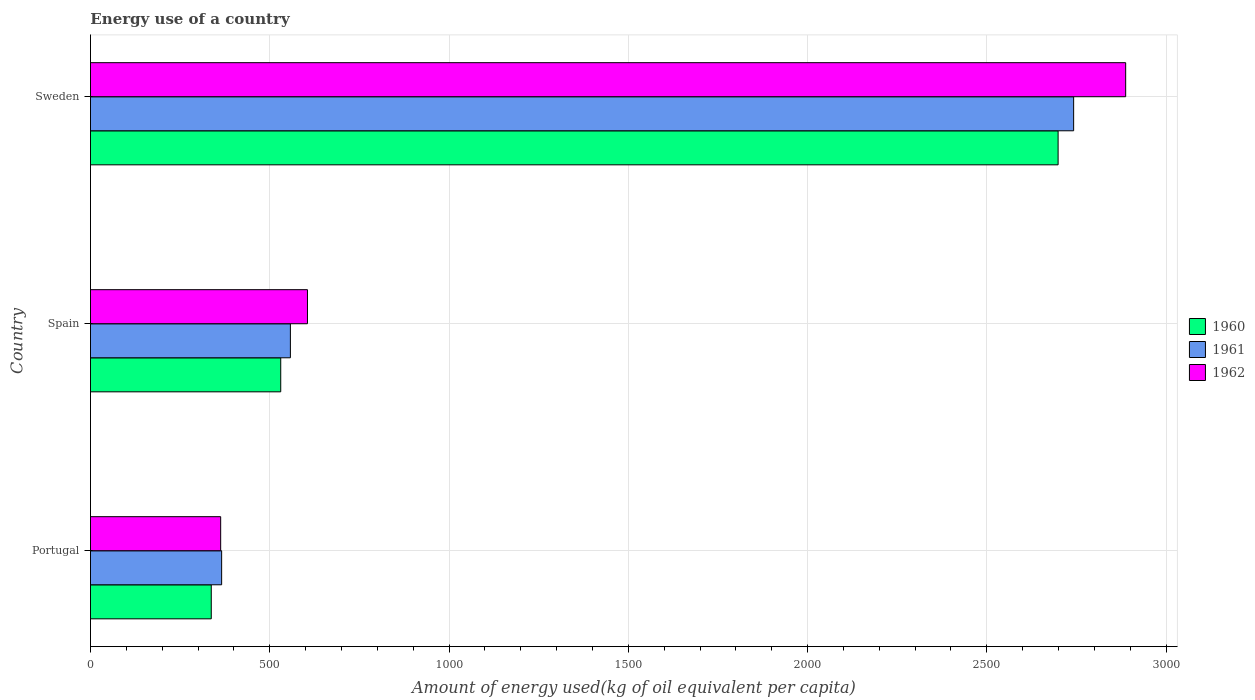How many groups of bars are there?
Make the answer very short. 3. What is the amount of energy used in in 1960 in Spain?
Make the answer very short. 530.66. Across all countries, what is the maximum amount of energy used in in 1962?
Your response must be concise. 2887.24. Across all countries, what is the minimum amount of energy used in in 1960?
Ensure brevity in your answer.  336.91. In which country was the amount of energy used in in 1961 maximum?
Your response must be concise. Sweden. What is the total amount of energy used in in 1960 in the graph?
Your response must be concise. 3566.37. What is the difference between the amount of energy used in in 1962 in Portugal and that in Sweden?
Your answer should be compact. -2524.07. What is the difference between the amount of energy used in in 1962 in Spain and the amount of energy used in in 1961 in Portugal?
Your answer should be compact. 239.38. What is the average amount of energy used in in 1961 per country?
Make the answer very short. 1221.85. What is the difference between the amount of energy used in in 1960 and amount of energy used in in 1962 in Sweden?
Keep it short and to the point. -188.44. What is the ratio of the amount of energy used in in 1961 in Spain to that in Sweden?
Your answer should be compact. 0.2. What is the difference between the highest and the second highest amount of energy used in in 1960?
Offer a very short reply. 2168.13. What is the difference between the highest and the lowest amount of energy used in in 1961?
Your response must be concise. 2376.28. What does the 2nd bar from the bottom in Sweden represents?
Offer a terse response. 1961. How many bars are there?
Your response must be concise. 9. Are all the bars in the graph horizontal?
Give a very brief answer. Yes. What is the difference between two consecutive major ticks on the X-axis?
Your answer should be compact. 500. Are the values on the major ticks of X-axis written in scientific E-notation?
Your answer should be very brief. No. Does the graph contain any zero values?
Provide a short and direct response. No. How are the legend labels stacked?
Your answer should be compact. Vertical. What is the title of the graph?
Keep it short and to the point. Energy use of a country. What is the label or title of the X-axis?
Ensure brevity in your answer.  Amount of energy used(kg of oil equivalent per capita). What is the label or title of the Y-axis?
Give a very brief answer. Country. What is the Amount of energy used(kg of oil equivalent per capita) in 1960 in Portugal?
Your answer should be very brief. 336.91. What is the Amount of energy used(kg of oil equivalent per capita) of 1961 in Portugal?
Provide a succinct answer. 365.84. What is the Amount of energy used(kg of oil equivalent per capita) of 1962 in Portugal?
Make the answer very short. 363.16. What is the Amount of energy used(kg of oil equivalent per capita) of 1960 in Spain?
Provide a succinct answer. 530.66. What is the Amount of energy used(kg of oil equivalent per capita) in 1961 in Spain?
Keep it short and to the point. 557.6. What is the Amount of energy used(kg of oil equivalent per capita) of 1962 in Spain?
Provide a short and direct response. 605.22. What is the Amount of energy used(kg of oil equivalent per capita) of 1960 in Sweden?
Provide a succinct answer. 2698.79. What is the Amount of energy used(kg of oil equivalent per capita) of 1961 in Sweden?
Your response must be concise. 2742.12. What is the Amount of energy used(kg of oil equivalent per capita) of 1962 in Sweden?
Provide a succinct answer. 2887.24. Across all countries, what is the maximum Amount of energy used(kg of oil equivalent per capita) of 1960?
Ensure brevity in your answer.  2698.79. Across all countries, what is the maximum Amount of energy used(kg of oil equivalent per capita) of 1961?
Offer a very short reply. 2742.12. Across all countries, what is the maximum Amount of energy used(kg of oil equivalent per capita) of 1962?
Offer a very short reply. 2887.24. Across all countries, what is the minimum Amount of energy used(kg of oil equivalent per capita) of 1960?
Your answer should be compact. 336.91. Across all countries, what is the minimum Amount of energy used(kg of oil equivalent per capita) of 1961?
Provide a succinct answer. 365.84. Across all countries, what is the minimum Amount of energy used(kg of oil equivalent per capita) of 1962?
Offer a very short reply. 363.16. What is the total Amount of energy used(kg of oil equivalent per capita) of 1960 in the graph?
Provide a short and direct response. 3566.37. What is the total Amount of energy used(kg of oil equivalent per capita) of 1961 in the graph?
Provide a succinct answer. 3665.56. What is the total Amount of energy used(kg of oil equivalent per capita) in 1962 in the graph?
Offer a terse response. 3855.62. What is the difference between the Amount of energy used(kg of oil equivalent per capita) of 1960 in Portugal and that in Spain?
Your answer should be very brief. -193.75. What is the difference between the Amount of energy used(kg of oil equivalent per capita) in 1961 in Portugal and that in Spain?
Your answer should be compact. -191.76. What is the difference between the Amount of energy used(kg of oil equivalent per capita) in 1962 in Portugal and that in Spain?
Give a very brief answer. -242.06. What is the difference between the Amount of energy used(kg of oil equivalent per capita) in 1960 in Portugal and that in Sweden?
Keep it short and to the point. -2361.88. What is the difference between the Amount of energy used(kg of oil equivalent per capita) of 1961 in Portugal and that in Sweden?
Provide a succinct answer. -2376.28. What is the difference between the Amount of energy used(kg of oil equivalent per capita) of 1962 in Portugal and that in Sweden?
Ensure brevity in your answer.  -2524.07. What is the difference between the Amount of energy used(kg of oil equivalent per capita) of 1960 in Spain and that in Sweden?
Make the answer very short. -2168.13. What is the difference between the Amount of energy used(kg of oil equivalent per capita) of 1961 in Spain and that in Sweden?
Give a very brief answer. -2184.52. What is the difference between the Amount of energy used(kg of oil equivalent per capita) of 1962 in Spain and that in Sweden?
Your response must be concise. -2282.01. What is the difference between the Amount of energy used(kg of oil equivalent per capita) in 1960 in Portugal and the Amount of energy used(kg of oil equivalent per capita) in 1961 in Spain?
Make the answer very short. -220.69. What is the difference between the Amount of energy used(kg of oil equivalent per capita) of 1960 in Portugal and the Amount of energy used(kg of oil equivalent per capita) of 1962 in Spain?
Offer a very short reply. -268.31. What is the difference between the Amount of energy used(kg of oil equivalent per capita) in 1961 in Portugal and the Amount of energy used(kg of oil equivalent per capita) in 1962 in Spain?
Your answer should be compact. -239.38. What is the difference between the Amount of energy used(kg of oil equivalent per capita) of 1960 in Portugal and the Amount of energy used(kg of oil equivalent per capita) of 1961 in Sweden?
Ensure brevity in your answer.  -2405.21. What is the difference between the Amount of energy used(kg of oil equivalent per capita) of 1960 in Portugal and the Amount of energy used(kg of oil equivalent per capita) of 1962 in Sweden?
Provide a short and direct response. -2550.32. What is the difference between the Amount of energy used(kg of oil equivalent per capita) of 1961 in Portugal and the Amount of energy used(kg of oil equivalent per capita) of 1962 in Sweden?
Provide a succinct answer. -2521.4. What is the difference between the Amount of energy used(kg of oil equivalent per capita) in 1960 in Spain and the Amount of energy used(kg of oil equivalent per capita) in 1961 in Sweden?
Make the answer very short. -2211.46. What is the difference between the Amount of energy used(kg of oil equivalent per capita) of 1960 in Spain and the Amount of energy used(kg of oil equivalent per capita) of 1962 in Sweden?
Provide a succinct answer. -2356.57. What is the difference between the Amount of energy used(kg of oil equivalent per capita) of 1961 in Spain and the Amount of energy used(kg of oil equivalent per capita) of 1962 in Sweden?
Ensure brevity in your answer.  -2329.64. What is the average Amount of energy used(kg of oil equivalent per capita) of 1960 per country?
Offer a very short reply. 1188.79. What is the average Amount of energy used(kg of oil equivalent per capita) of 1961 per country?
Ensure brevity in your answer.  1221.85. What is the average Amount of energy used(kg of oil equivalent per capita) of 1962 per country?
Your answer should be compact. 1285.21. What is the difference between the Amount of energy used(kg of oil equivalent per capita) of 1960 and Amount of energy used(kg of oil equivalent per capita) of 1961 in Portugal?
Ensure brevity in your answer.  -28.93. What is the difference between the Amount of energy used(kg of oil equivalent per capita) in 1960 and Amount of energy used(kg of oil equivalent per capita) in 1962 in Portugal?
Give a very brief answer. -26.25. What is the difference between the Amount of energy used(kg of oil equivalent per capita) of 1961 and Amount of energy used(kg of oil equivalent per capita) of 1962 in Portugal?
Make the answer very short. 2.68. What is the difference between the Amount of energy used(kg of oil equivalent per capita) in 1960 and Amount of energy used(kg of oil equivalent per capita) in 1961 in Spain?
Keep it short and to the point. -26.93. What is the difference between the Amount of energy used(kg of oil equivalent per capita) in 1960 and Amount of energy used(kg of oil equivalent per capita) in 1962 in Spain?
Keep it short and to the point. -74.56. What is the difference between the Amount of energy used(kg of oil equivalent per capita) in 1961 and Amount of energy used(kg of oil equivalent per capita) in 1962 in Spain?
Offer a very short reply. -47.62. What is the difference between the Amount of energy used(kg of oil equivalent per capita) in 1960 and Amount of energy used(kg of oil equivalent per capita) in 1961 in Sweden?
Offer a terse response. -43.33. What is the difference between the Amount of energy used(kg of oil equivalent per capita) in 1960 and Amount of energy used(kg of oil equivalent per capita) in 1962 in Sweden?
Your answer should be very brief. -188.44. What is the difference between the Amount of energy used(kg of oil equivalent per capita) in 1961 and Amount of energy used(kg of oil equivalent per capita) in 1962 in Sweden?
Keep it short and to the point. -145.11. What is the ratio of the Amount of energy used(kg of oil equivalent per capita) of 1960 in Portugal to that in Spain?
Your answer should be compact. 0.63. What is the ratio of the Amount of energy used(kg of oil equivalent per capita) of 1961 in Portugal to that in Spain?
Offer a terse response. 0.66. What is the ratio of the Amount of energy used(kg of oil equivalent per capita) in 1962 in Portugal to that in Spain?
Offer a very short reply. 0.6. What is the ratio of the Amount of energy used(kg of oil equivalent per capita) of 1960 in Portugal to that in Sweden?
Ensure brevity in your answer.  0.12. What is the ratio of the Amount of energy used(kg of oil equivalent per capita) of 1961 in Portugal to that in Sweden?
Keep it short and to the point. 0.13. What is the ratio of the Amount of energy used(kg of oil equivalent per capita) of 1962 in Portugal to that in Sweden?
Make the answer very short. 0.13. What is the ratio of the Amount of energy used(kg of oil equivalent per capita) in 1960 in Spain to that in Sweden?
Give a very brief answer. 0.2. What is the ratio of the Amount of energy used(kg of oil equivalent per capita) in 1961 in Spain to that in Sweden?
Offer a very short reply. 0.2. What is the ratio of the Amount of energy used(kg of oil equivalent per capita) of 1962 in Spain to that in Sweden?
Make the answer very short. 0.21. What is the difference between the highest and the second highest Amount of energy used(kg of oil equivalent per capita) in 1960?
Keep it short and to the point. 2168.13. What is the difference between the highest and the second highest Amount of energy used(kg of oil equivalent per capita) in 1961?
Make the answer very short. 2184.52. What is the difference between the highest and the second highest Amount of energy used(kg of oil equivalent per capita) in 1962?
Offer a terse response. 2282.01. What is the difference between the highest and the lowest Amount of energy used(kg of oil equivalent per capita) of 1960?
Make the answer very short. 2361.88. What is the difference between the highest and the lowest Amount of energy used(kg of oil equivalent per capita) of 1961?
Your answer should be very brief. 2376.28. What is the difference between the highest and the lowest Amount of energy used(kg of oil equivalent per capita) of 1962?
Your response must be concise. 2524.07. 